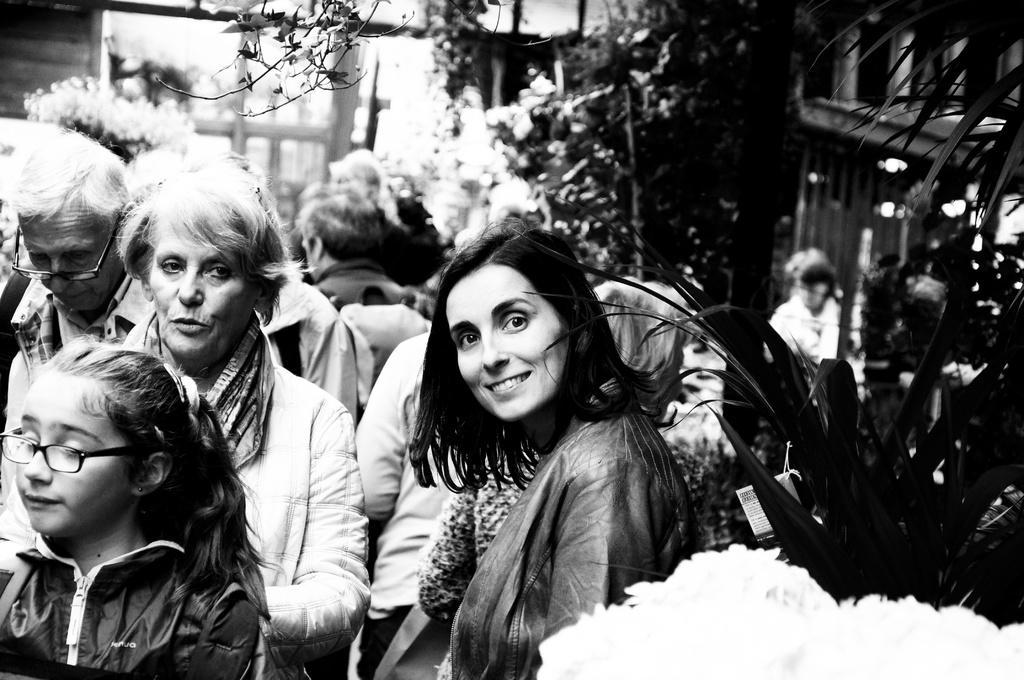Please provide a concise description of this image. This picture describes about group of people, few people wore spectacles, in the middle of the image we can see a woman, she is smiling, in the background we can find few trees. 